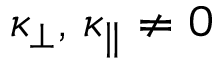Convert formula to latex. <formula><loc_0><loc_0><loc_500><loc_500>\kappa _ { \perp } , \, \kappa _ { \| } \neq 0</formula> 